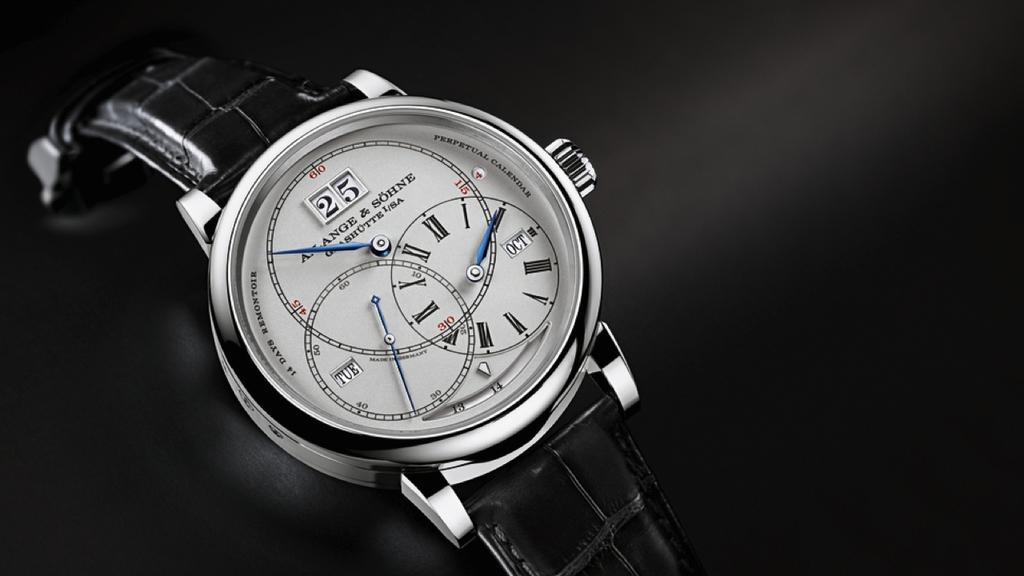<image>
Offer a succinct explanation of the picture presented. Black and white A Lange & Sohne watch. 